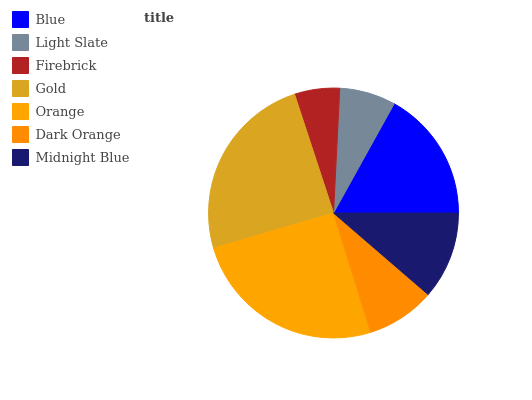Is Firebrick the minimum?
Answer yes or no. Yes. Is Orange the maximum?
Answer yes or no. Yes. Is Light Slate the minimum?
Answer yes or no. No. Is Light Slate the maximum?
Answer yes or no. No. Is Blue greater than Light Slate?
Answer yes or no. Yes. Is Light Slate less than Blue?
Answer yes or no. Yes. Is Light Slate greater than Blue?
Answer yes or no. No. Is Blue less than Light Slate?
Answer yes or no. No. Is Midnight Blue the high median?
Answer yes or no. Yes. Is Midnight Blue the low median?
Answer yes or no. Yes. Is Blue the high median?
Answer yes or no. No. Is Dark Orange the low median?
Answer yes or no. No. 